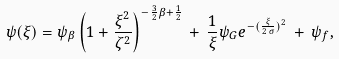<formula> <loc_0><loc_0><loc_500><loc_500>\psi ( \xi ) = \psi _ { \beta } \left ( 1 + \frac { \xi ^ { 2 } } { \zeta ^ { 2 } } \right ) ^ { - \frac { 3 } { 2 } \beta + \frac { 1 } { 2 } } \, + \, \frac { 1 } { \xi } \psi _ { G } e ^ { - ( \frac { \xi } { 2 \, \sigma } ) ^ { 2 } } \, + \, \psi _ { f } ,</formula> 